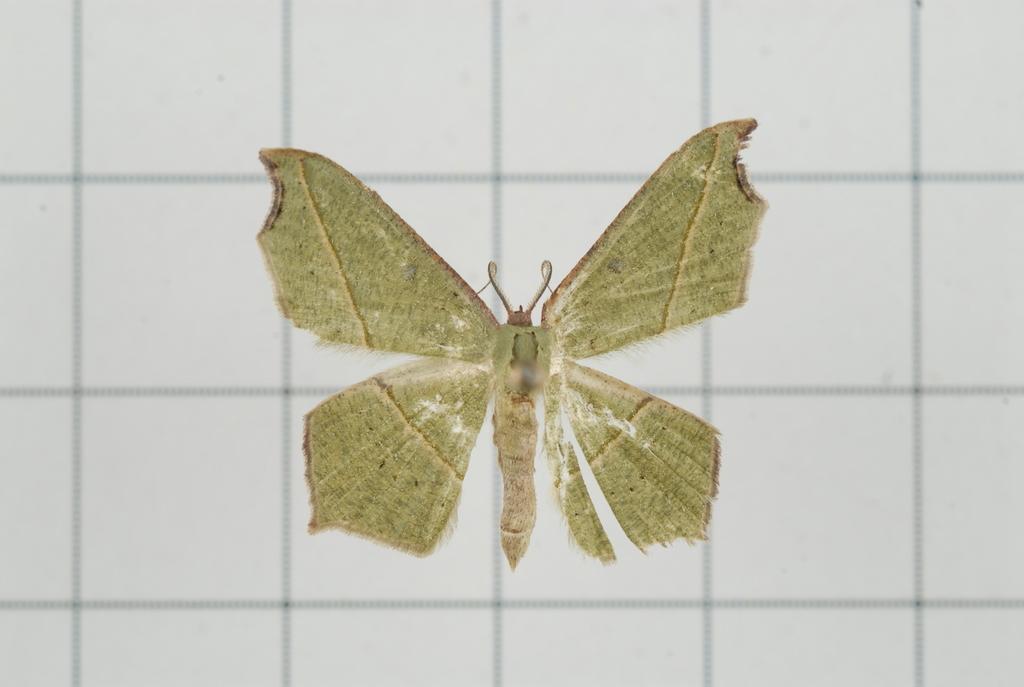In one or two sentences, can you explain what this image depicts? In the background we can see the wall tiles. In this picture we can see a butterfly. 